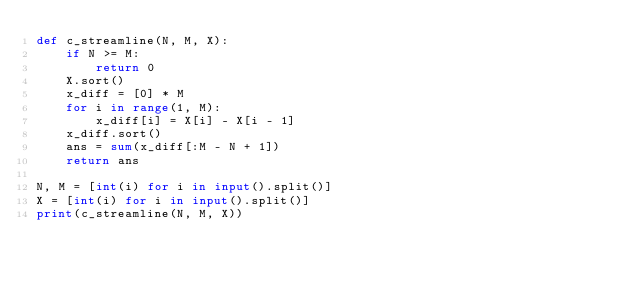Convert code to text. <code><loc_0><loc_0><loc_500><loc_500><_Python_>def c_streamline(N, M, X):
    if N >= M:
        return 0
    X.sort()
    x_diff = [0] * M
    for i in range(1, M):
        x_diff[i] = X[i] - X[i - 1]
    x_diff.sort()
    ans = sum(x_diff[:M - N + 1])
    return ans

N, M = [int(i) for i in input().split()]
X = [int(i) for i in input().split()]
print(c_streamline(N, M, X))</code> 